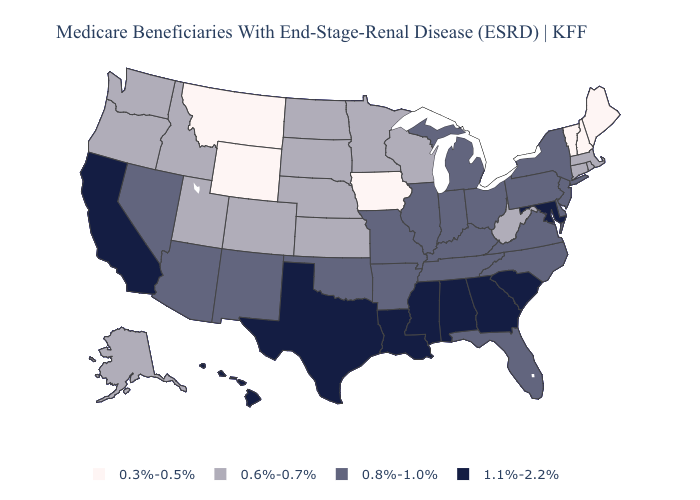Does Arizona have the highest value in the USA?
Write a very short answer. No. What is the lowest value in the Northeast?
Quick response, please. 0.3%-0.5%. Name the states that have a value in the range 0.3%-0.5%?
Quick response, please. Iowa, Maine, Montana, New Hampshire, Vermont, Wyoming. What is the value of Iowa?
Be succinct. 0.3%-0.5%. How many symbols are there in the legend?
Be succinct. 4. What is the value of Pennsylvania?
Write a very short answer. 0.8%-1.0%. Which states have the highest value in the USA?
Concise answer only. Alabama, California, Georgia, Hawaii, Louisiana, Maryland, Mississippi, South Carolina, Texas. What is the highest value in states that border Texas?
Keep it brief. 1.1%-2.2%. Name the states that have a value in the range 0.3%-0.5%?
Answer briefly. Iowa, Maine, Montana, New Hampshire, Vermont, Wyoming. Does Wisconsin have the highest value in the USA?
Concise answer only. No. What is the value of Colorado?
Keep it brief. 0.6%-0.7%. Name the states that have a value in the range 0.6%-0.7%?
Concise answer only. Alaska, Colorado, Connecticut, Idaho, Kansas, Massachusetts, Minnesota, Nebraska, North Dakota, Oregon, Rhode Island, South Dakota, Utah, Washington, West Virginia, Wisconsin. What is the value of Minnesota?
Keep it brief. 0.6%-0.7%. Name the states that have a value in the range 0.6%-0.7%?
Concise answer only. Alaska, Colorado, Connecticut, Idaho, Kansas, Massachusetts, Minnesota, Nebraska, North Dakota, Oregon, Rhode Island, South Dakota, Utah, Washington, West Virginia, Wisconsin. What is the value of Delaware?
Quick response, please. 0.8%-1.0%. 